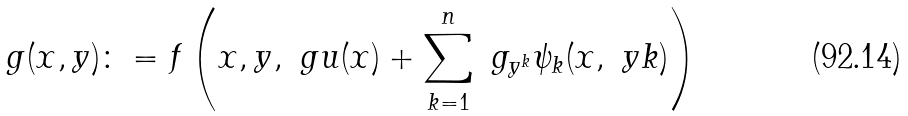<formula> <loc_0><loc_0><loc_500><loc_500>g ( x , y ) \colon = f \left ( x , y , \ g u ( x ) + \sum _ { k = 1 } ^ { n } \ g _ { y ^ { k } } \psi _ { k } ( x , \ y k ) \right )</formula> 